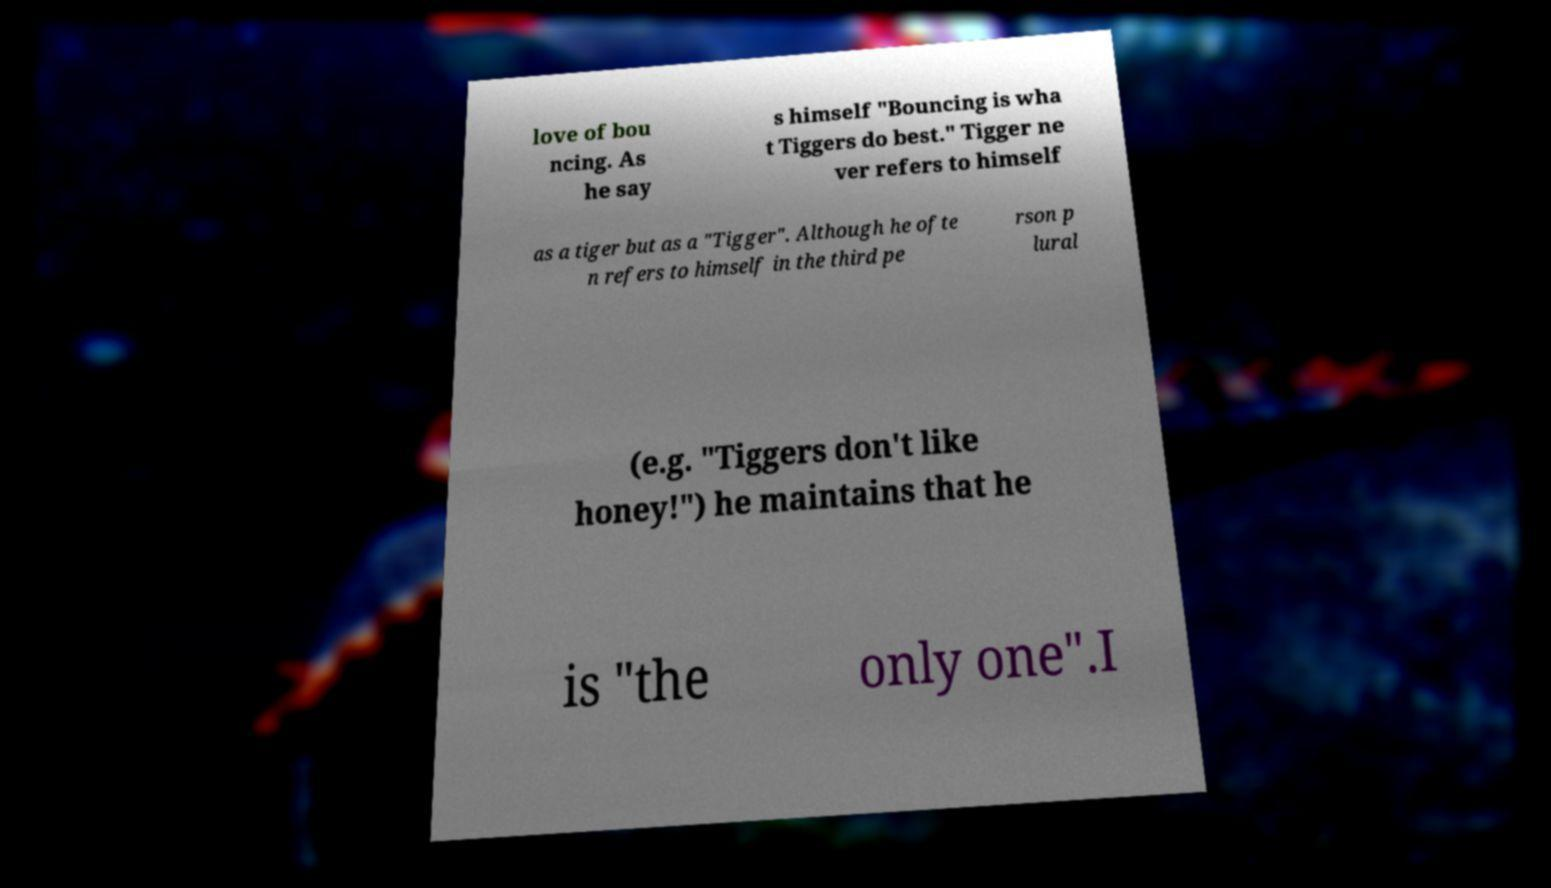Can you accurately transcribe the text from the provided image for me? love of bou ncing. As he say s himself "Bouncing is wha t Tiggers do best." Tigger ne ver refers to himself as a tiger but as a "Tigger". Although he ofte n refers to himself in the third pe rson p lural (e.g. "Tiggers don't like honey!") he maintains that he is "the only one".I 